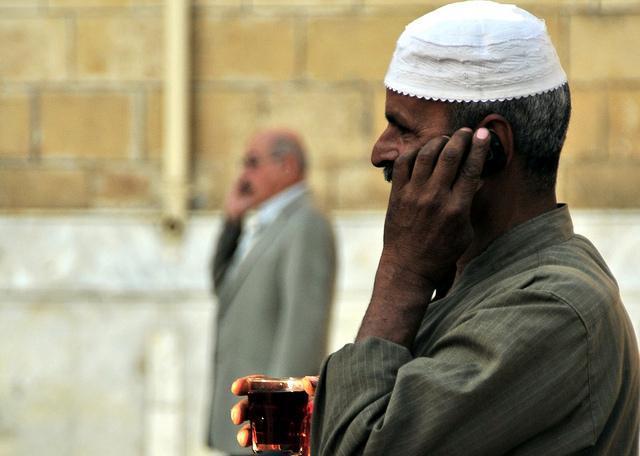How many people are there?
Give a very brief answer. 2. How many zebras have their back turned to the camera?
Give a very brief answer. 0. 